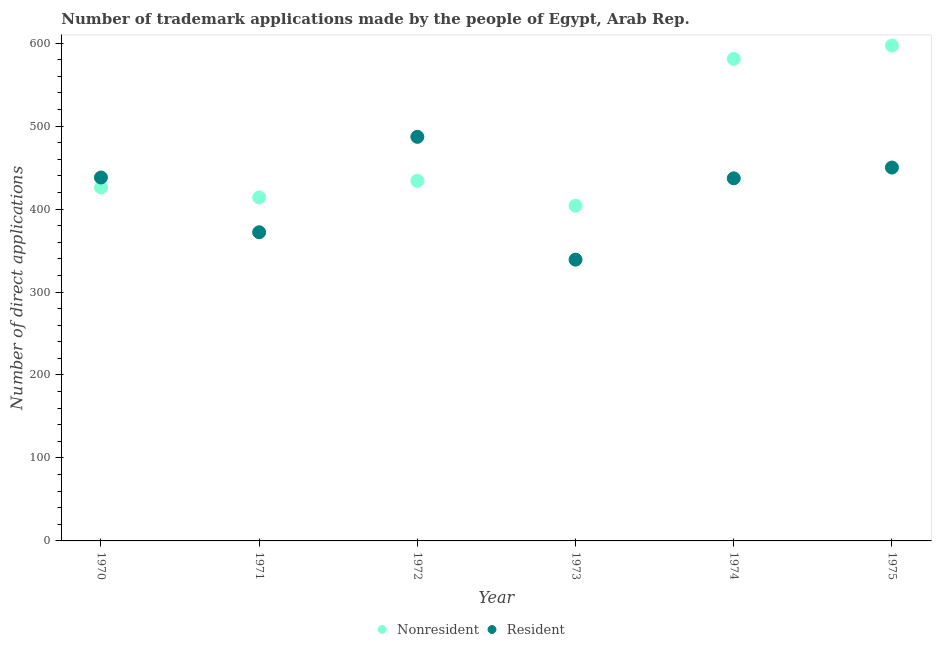How many different coloured dotlines are there?
Offer a terse response. 2. Is the number of dotlines equal to the number of legend labels?
Your answer should be very brief. Yes. What is the number of trademark applications made by residents in 1972?
Ensure brevity in your answer.  487. Across all years, what is the maximum number of trademark applications made by non residents?
Provide a succinct answer. 597. Across all years, what is the minimum number of trademark applications made by residents?
Your answer should be very brief. 339. In which year was the number of trademark applications made by non residents maximum?
Ensure brevity in your answer.  1975. What is the total number of trademark applications made by non residents in the graph?
Give a very brief answer. 2856. What is the difference between the number of trademark applications made by residents in 1972 and that in 1973?
Make the answer very short. 148. What is the difference between the number of trademark applications made by non residents in 1975 and the number of trademark applications made by residents in 1971?
Make the answer very short. 225. What is the average number of trademark applications made by residents per year?
Ensure brevity in your answer.  420.5. In the year 1972, what is the difference between the number of trademark applications made by residents and number of trademark applications made by non residents?
Provide a succinct answer. 53. In how many years, is the number of trademark applications made by non residents greater than 440?
Your answer should be compact. 2. What is the ratio of the number of trademark applications made by residents in 1970 to that in 1972?
Your answer should be compact. 0.9. What is the difference between the highest and the lowest number of trademark applications made by residents?
Your answer should be very brief. 148. Is the sum of the number of trademark applications made by non residents in 1970 and 1975 greater than the maximum number of trademark applications made by residents across all years?
Offer a very short reply. Yes. Is the number of trademark applications made by residents strictly greater than the number of trademark applications made by non residents over the years?
Offer a terse response. No. Is the number of trademark applications made by non residents strictly less than the number of trademark applications made by residents over the years?
Offer a very short reply. No. How many dotlines are there?
Your response must be concise. 2. What is the difference between two consecutive major ticks on the Y-axis?
Your response must be concise. 100. Are the values on the major ticks of Y-axis written in scientific E-notation?
Your answer should be compact. No. Does the graph contain any zero values?
Your response must be concise. No. Does the graph contain grids?
Your response must be concise. No. Where does the legend appear in the graph?
Your answer should be compact. Bottom center. How are the legend labels stacked?
Offer a terse response. Horizontal. What is the title of the graph?
Make the answer very short. Number of trademark applications made by the people of Egypt, Arab Rep. Does "Urban agglomerations" appear as one of the legend labels in the graph?
Offer a very short reply. No. What is the label or title of the X-axis?
Your response must be concise. Year. What is the label or title of the Y-axis?
Keep it short and to the point. Number of direct applications. What is the Number of direct applications of Nonresident in 1970?
Give a very brief answer. 426. What is the Number of direct applications in Resident in 1970?
Offer a terse response. 438. What is the Number of direct applications of Nonresident in 1971?
Your answer should be very brief. 414. What is the Number of direct applications of Resident in 1971?
Make the answer very short. 372. What is the Number of direct applications in Nonresident in 1972?
Your answer should be very brief. 434. What is the Number of direct applications in Resident in 1972?
Your answer should be very brief. 487. What is the Number of direct applications of Nonresident in 1973?
Offer a very short reply. 404. What is the Number of direct applications of Resident in 1973?
Ensure brevity in your answer.  339. What is the Number of direct applications of Nonresident in 1974?
Provide a succinct answer. 581. What is the Number of direct applications of Resident in 1974?
Your response must be concise. 437. What is the Number of direct applications of Nonresident in 1975?
Ensure brevity in your answer.  597. What is the Number of direct applications in Resident in 1975?
Keep it short and to the point. 450. Across all years, what is the maximum Number of direct applications in Nonresident?
Offer a terse response. 597. Across all years, what is the maximum Number of direct applications of Resident?
Your response must be concise. 487. Across all years, what is the minimum Number of direct applications of Nonresident?
Provide a short and direct response. 404. Across all years, what is the minimum Number of direct applications in Resident?
Provide a short and direct response. 339. What is the total Number of direct applications in Nonresident in the graph?
Offer a terse response. 2856. What is the total Number of direct applications in Resident in the graph?
Your answer should be very brief. 2523. What is the difference between the Number of direct applications of Nonresident in 1970 and that in 1972?
Make the answer very short. -8. What is the difference between the Number of direct applications of Resident in 1970 and that in 1972?
Provide a short and direct response. -49. What is the difference between the Number of direct applications of Nonresident in 1970 and that in 1973?
Make the answer very short. 22. What is the difference between the Number of direct applications of Resident in 1970 and that in 1973?
Offer a terse response. 99. What is the difference between the Number of direct applications of Nonresident in 1970 and that in 1974?
Provide a succinct answer. -155. What is the difference between the Number of direct applications in Resident in 1970 and that in 1974?
Your answer should be compact. 1. What is the difference between the Number of direct applications of Nonresident in 1970 and that in 1975?
Your answer should be compact. -171. What is the difference between the Number of direct applications in Nonresident in 1971 and that in 1972?
Your response must be concise. -20. What is the difference between the Number of direct applications in Resident in 1971 and that in 1972?
Provide a short and direct response. -115. What is the difference between the Number of direct applications in Resident in 1971 and that in 1973?
Give a very brief answer. 33. What is the difference between the Number of direct applications of Nonresident in 1971 and that in 1974?
Provide a short and direct response. -167. What is the difference between the Number of direct applications in Resident in 1971 and that in 1974?
Your response must be concise. -65. What is the difference between the Number of direct applications in Nonresident in 1971 and that in 1975?
Give a very brief answer. -183. What is the difference between the Number of direct applications in Resident in 1971 and that in 1975?
Give a very brief answer. -78. What is the difference between the Number of direct applications of Resident in 1972 and that in 1973?
Offer a terse response. 148. What is the difference between the Number of direct applications in Nonresident in 1972 and that in 1974?
Keep it short and to the point. -147. What is the difference between the Number of direct applications of Nonresident in 1972 and that in 1975?
Ensure brevity in your answer.  -163. What is the difference between the Number of direct applications in Resident in 1972 and that in 1975?
Provide a short and direct response. 37. What is the difference between the Number of direct applications in Nonresident in 1973 and that in 1974?
Your response must be concise. -177. What is the difference between the Number of direct applications of Resident in 1973 and that in 1974?
Offer a terse response. -98. What is the difference between the Number of direct applications of Nonresident in 1973 and that in 1975?
Make the answer very short. -193. What is the difference between the Number of direct applications of Resident in 1973 and that in 1975?
Ensure brevity in your answer.  -111. What is the difference between the Number of direct applications of Nonresident in 1974 and that in 1975?
Make the answer very short. -16. What is the difference between the Number of direct applications in Nonresident in 1970 and the Number of direct applications in Resident in 1971?
Offer a terse response. 54. What is the difference between the Number of direct applications of Nonresident in 1970 and the Number of direct applications of Resident in 1972?
Your answer should be very brief. -61. What is the difference between the Number of direct applications of Nonresident in 1970 and the Number of direct applications of Resident in 1973?
Your answer should be compact. 87. What is the difference between the Number of direct applications of Nonresident in 1970 and the Number of direct applications of Resident in 1974?
Make the answer very short. -11. What is the difference between the Number of direct applications in Nonresident in 1970 and the Number of direct applications in Resident in 1975?
Provide a succinct answer. -24. What is the difference between the Number of direct applications of Nonresident in 1971 and the Number of direct applications of Resident in 1972?
Provide a short and direct response. -73. What is the difference between the Number of direct applications of Nonresident in 1971 and the Number of direct applications of Resident in 1975?
Ensure brevity in your answer.  -36. What is the difference between the Number of direct applications of Nonresident in 1973 and the Number of direct applications of Resident in 1974?
Your answer should be compact. -33. What is the difference between the Number of direct applications of Nonresident in 1973 and the Number of direct applications of Resident in 1975?
Offer a terse response. -46. What is the difference between the Number of direct applications of Nonresident in 1974 and the Number of direct applications of Resident in 1975?
Your response must be concise. 131. What is the average Number of direct applications in Nonresident per year?
Offer a very short reply. 476. What is the average Number of direct applications in Resident per year?
Provide a short and direct response. 420.5. In the year 1972, what is the difference between the Number of direct applications in Nonresident and Number of direct applications in Resident?
Provide a short and direct response. -53. In the year 1973, what is the difference between the Number of direct applications of Nonresident and Number of direct applications of Resident?
Keep it short and to the point. 65. In the year 1974, what is the difference between the Number of direct applications of Nonresident and Number of direct applications of Resident?
Offer a very short reply. 144. In the year 1975, what is the difference between the Number of direct applications in Nonresident and Number of direct applications in Resident?
Give a very brief answer. 147. What is the ratio of the Number of direct applications of Resident in 1970 to that in 1971?
Keep it short and to the point. 1.18. What is the ratio of the Number of direct applications in Nonresident in 1970 to that in 1972?
Make the answer very short. 0.98. What is the ratio of the Number of direct applications in Resident in 1970 to that in 1972?
Your answer should be compact. 0.9. What is the ratio of the Number of direct applications in Nonresident in 1970 to that in 1973?
Your answer should be very brief. 1.05. What is the ratio of the Number of direct applications of Resident in 1970 to that in 1973?
Keep it short and to the point. 1.29. What is the ratio of the Number of direct applications of Nonresident in 1970 to that in 1974?
Keep it short and to the point. 0.73. What is the ratio of the Number of direct applications in Nonresident in 1970 to that in 1975?
Your answer should be compact. 0.71. What is the ratio of the Number of direct applications in Resident in 1970 to that in 1975?
Your response must be concise. 0.97. What is the ratio of the Number of direct applications in Nonresident in 1971 to that in 1972?
Offer a very short reply. 0.95. What is the ratio of the Number of direct applications in Resident in 1971 to that in 1972?
Keep it short and to the point. 0.76. What is the ratio of the Number of direct applications of Nonresident in 1971 to that in 1973?
Give a very brief answer. 1.02. What is the ratio of the Number of direct applications of Resident in 1971 to that in 1973?
Give a very brief answer. 1.1. What is the ratio of the Number of direct applications in Nonresident in 1971 to that in 1974?
Ensure brevity in your answer.  0.71. What is the ratio of the Number of direct applications of Resident in 1971 to that in 1974?
Offer a terse response. 0.85. What is the ratio of the Number of direct applications in Nonresident in 1971 to that in 1975?
Your answer should be very brief. 0.69. What is the ratio of the Number of direct applications of Resident in 1971 to that in 1975?
Your response must be concise. 0.83. What is the ratio of the Number of direct applications in Nonresident in 1972 to that in 1973?
Your answer should be very brief. 1.07. What is the ratio of the Number of direct applications of Resident in 1972 to that in 1973?
Provide a succinct answer. 1.44. What is the ratio of the Number of direct applications of Nonresident in 1972 to that in 1974?
Offer a very short reply. 0.75. What is the ratio of the Number of direct applications in Resident in 1972 to that in 1974?
Offer a terse response. 1.11. What is the ratio of the Number of direct applications in Nonresident in 1972 to that in 1975?
Your answer should be compact. 0.73. What is the ratio of the Number of direct applications in Resident in 1972 to that in 1975?
Offer a very short reply. 1.08. What is the ratio of the Number of direct applications in Nonresident in 1973 to that in 1974?
Offer a terse response. 0.7. What is the ratio of the Number of direct applications of Resident in 1973 to that in 1974?
Give a very brief answer. 0.78. What is the ratio of the Number of direct applications of Nonresident in 1973 to that in 1975?
Provide a succinct answer. 0.68. What is the ratio of the Number of direct applications of Resident in 1973 to that in 1975?
Make the answer very short. 0.75. What is the ratio of the Number of direct applications of Nonresident in 1974 to that in 1975?
Provide a short and direct response. 0.97. What is the ratio of the Number of direct applications in Resident in 1974 to that in 1975?
Provide a short and direct response. 0.97. What is the difference between the highest and the second highest Number of direct applications of Resident?
Make the answer very short. 37. What is the difference between the highest and the lowest Number of direct applications of Nonresident?
Offer a terse response. 193. What is the difference between the highest and the lowest Number of direct applications in Resident?
Provide a succinct answer. 148. 